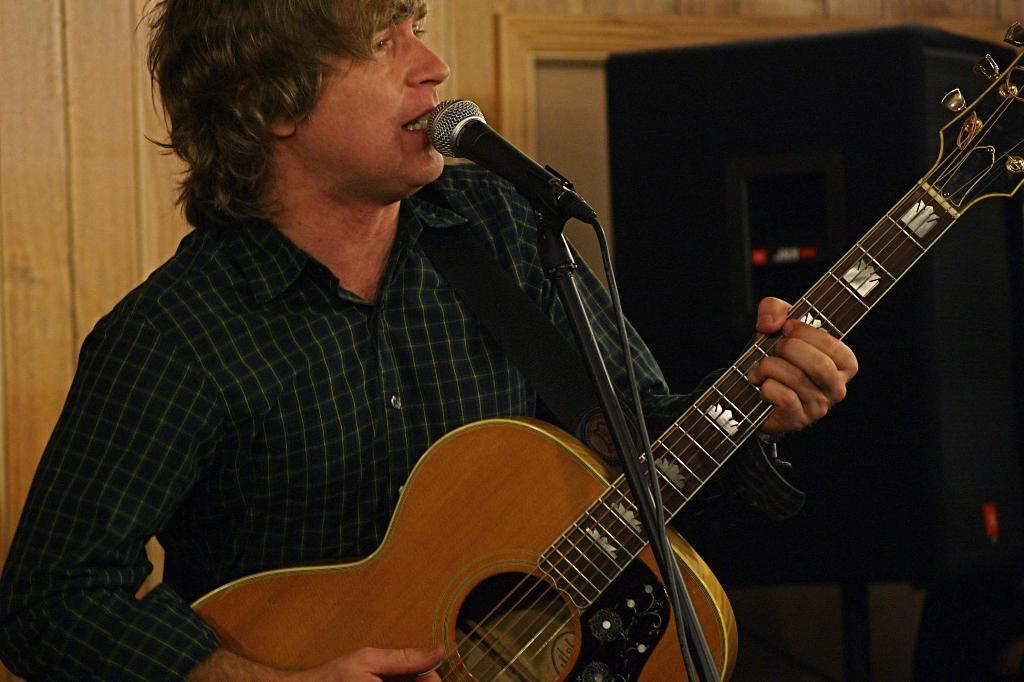What is the person in the image doing? The person is standing, playing a guitar, and singing. What object is the person using to amplify their voice? There is a microphone in the front of the image. What object is visible in the background that might be used to amplify sound? There is a speaker in the background of the image. What type of wire can be seen connecting the person to the speaker in the image? There is no wire connecting the person to the speaker in the image. How does the person's breath affect the sound of their singing in the image? The image does not provide information about the person's breath or its effect on their singing. 